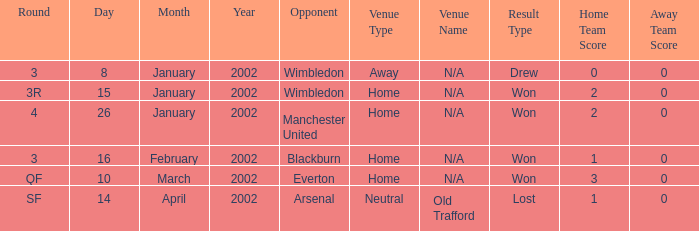What is the Date with a Opponent with wimbledon, and a Result of won 2-0? 15 January 2002. 